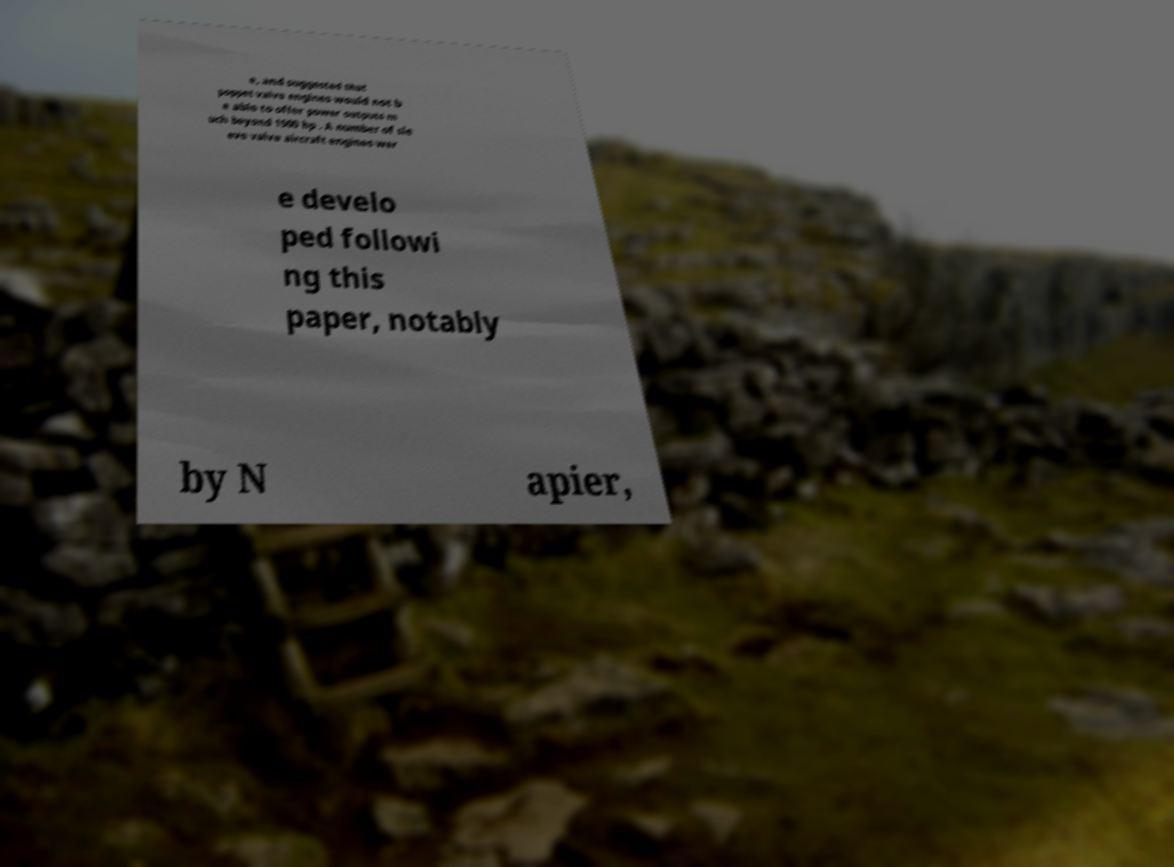Can you read and provide the text displayed in the image?This photo seems to have some interesting text. Can you extract and type it out for me? e, and suggested that poppet valve engines would not b e able to offer power outputs m uch beyond 1500 hp . A number of sle eve valve aircraft engines wer e develo ped followi ng this paper, notably by N apier, 